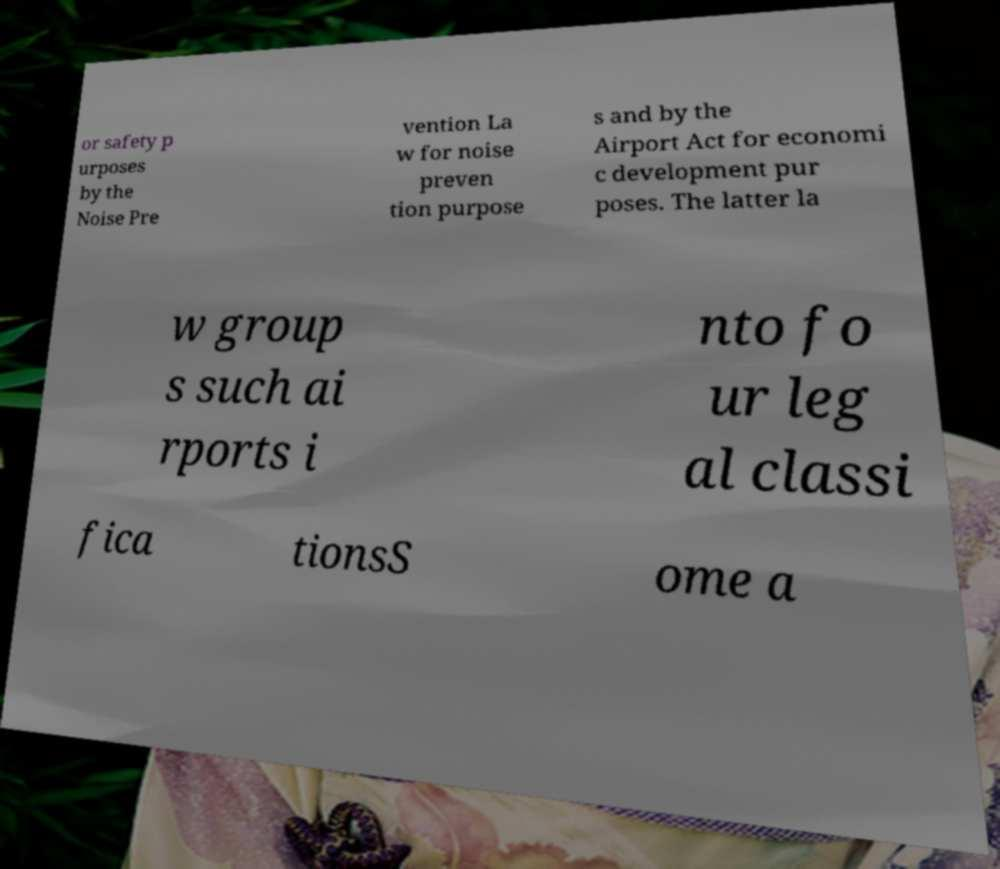For documentation purposes, I need the text within this image transcribed. Could you provide that? or safety p urposes by the Noise Pre vention La w for noise preven tion purpose s and by the Airport Act for economi c development pur poses. The latter la w group s such ai rports i nto fo ur leg al classi fica tionsS ome a 